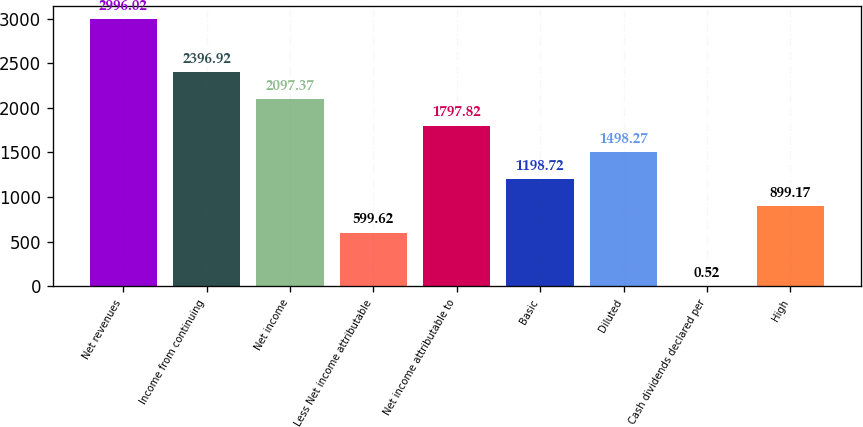Convert chart. <chart><loc_0><loc_0><loc_500><loc_500><bar_chart><fcel>Net revenues<fcel>Income from continuing<fcel>Net income<fcel>Less Net income attributable<fcel>Net income attributable to<fcel>Basic<fcel>Diluted<fcel>Cash dividends declared per<fcel>High<nl><fcel>2996.02<fcel>2396.92<fcel>2097.37<fcel>599.62<fcel>1797.82<fcel>1198.72<fcel>1498.27<fcel>0.52<fcel>899.17<nl></chart> 